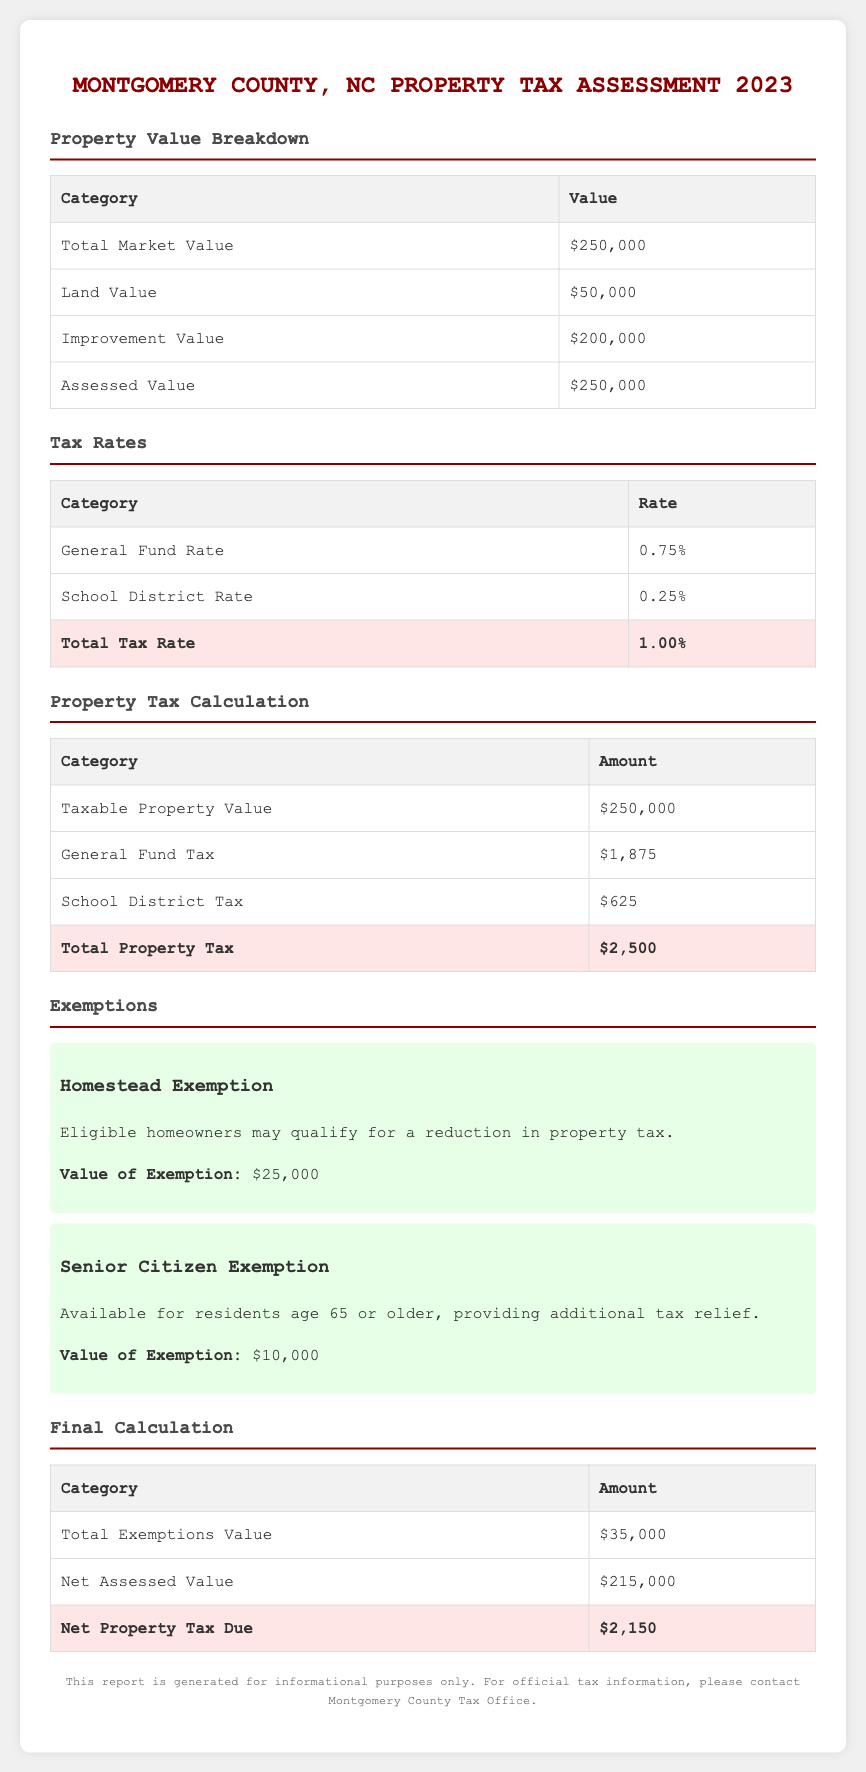What is the total market value? The total market value is listed in the Property Value Breakdown table.
Answer: $250,000 What is the general fund tax amount? The general fund tax is derived from the taxable property value at the specified general fund rate in the Property Tax Calculation table.
Answer: $1,875 What is the total property tax? The total property tax is the sum of the general fund tax and the school district tax calculated in the Property Tax Calculation table.
Answer: $2,500 What is the value of the homestead exemption? The value of the homestead exemption is mentioned in the Exemptions section of the document.
Answer: $25,000 What is the net property tax due? The net property tax due is calculated in the Final Calculation table, which factors in exemptions applied to the total assessed value.
Answer: $2,150 What is the school district rate? The school district rate can be found in the Tax Rates table under its respective category.
Answer: 0.25% What is the total exemptions value? The total exemptions value is provided in the Final Calculation table and reflects all exemption types combined.
Answer: $35,000 How much is the improvement value? The improvement value is detailed in the Property Value Breakdown table, indicating the assessed value of improvements on the property.
Answer: $200,000 What is the total tax rate? The total tax rate is the sum of all applicable tax rates listed in the Tax Rates table.
Answer: 1.00% What age must residents be to qualify for the senior citizen exemption? The eligibility for the senior citizen exemption is based on age mentioned in the document.
Answer: 65 years or older 